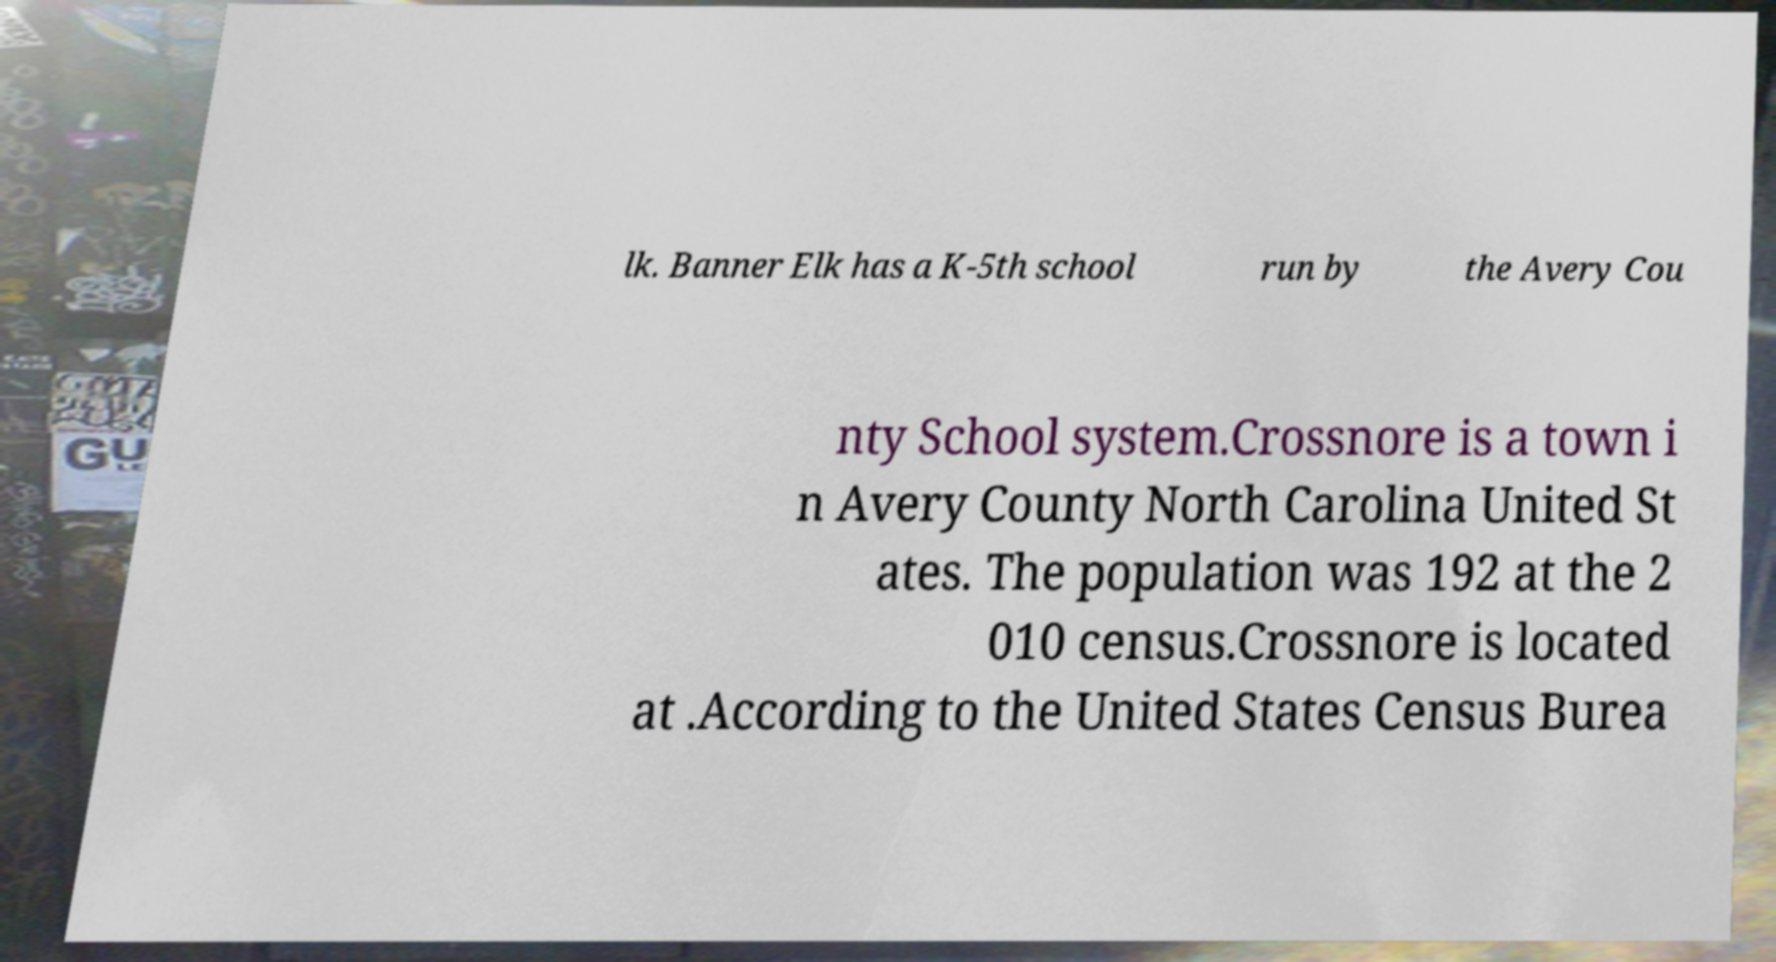Could you assist in decoding the text presented in this image and type it out clearly? lk. Banner Elk has a K-5th school run by the Avery Cou nty School system.Crossnore is a town i n Avery County North Carolina United St ates. The population was 192 at the 2 010 census.Crossnore is located at .According to the United States Census Burea 